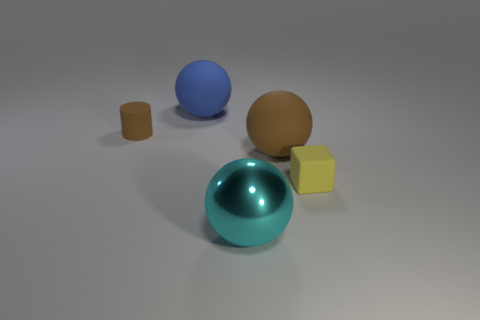Is the number of tiny matte cylinders in front of the large cyan thing greater than the number of metal objects? no 